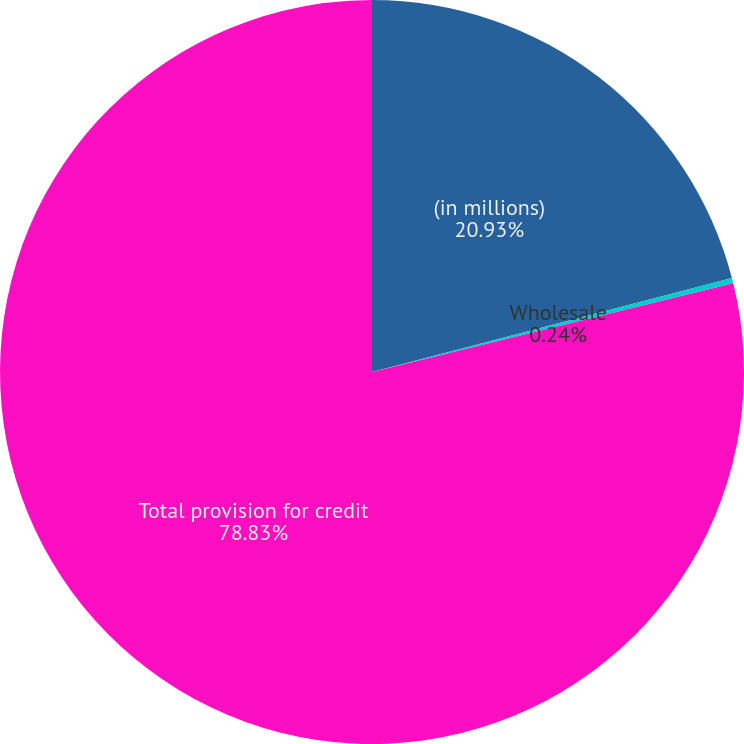<chart> <loc_0><loc_0><loc_500><loc_500><pie_chart><fcel>(in millions)<fcel>Wholesale<fcel>Total provision for credit<nl><fcel>20.93%<fcel>0.24%<fcel>78.83%<nl></chart> 